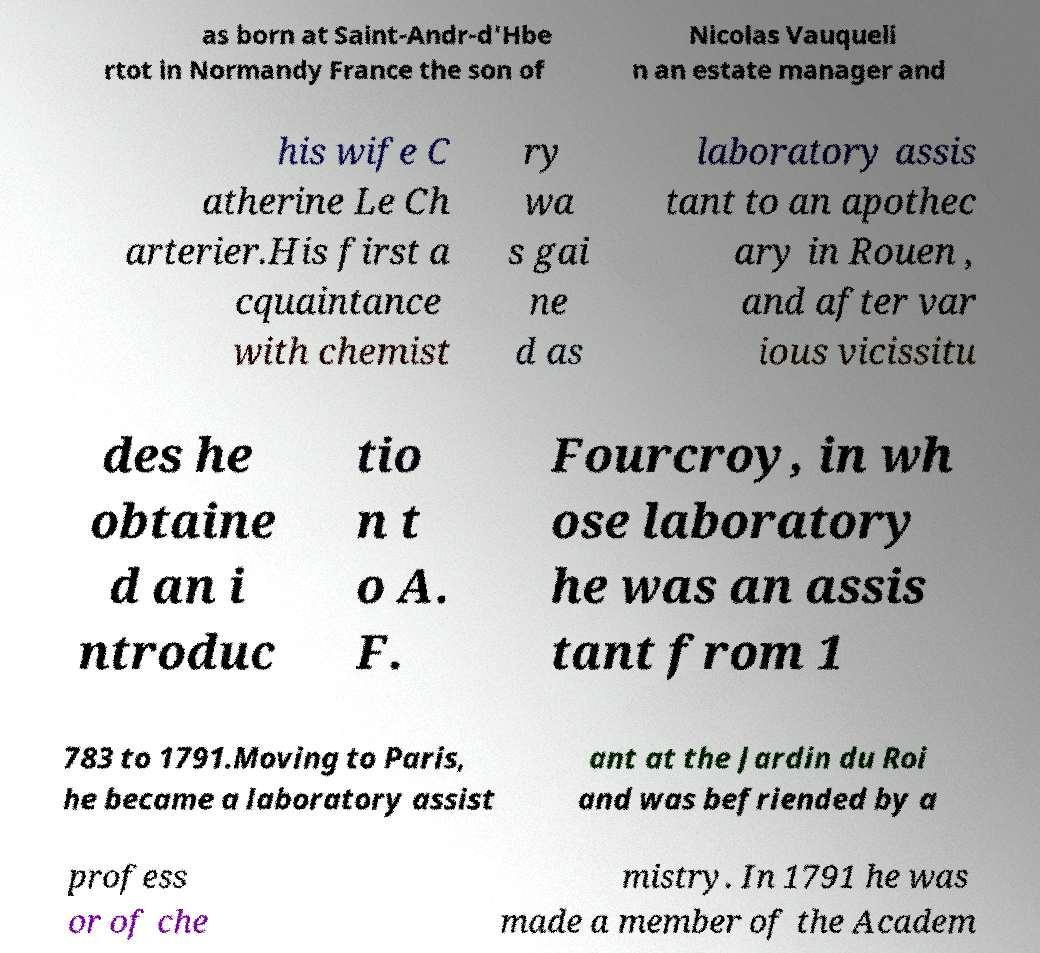I need the written content from this picture converted into text. Can you do that? as born at Saint-Andr-d'Hbe rtot in Normandy France the son of Nicolas Vauqueli n an estate manager and his wife C atherine Le Ch arterier.His first a cquaintance with chemist ry wa s gai ne d as laboratory assis tant to an apothec ary in Rouen , and after var ious vicissitu des he obtaine d an i ntroduc tio n t o A. F. Fourcroy, in wh ose laboratory he was an assis tant from 1 783 to 1791.Moving to Paris, he became a laboratory assist ant at the Jardin du Roi and was befriended by a profess or of che mistry. In 1791 he was made a member of the Academ 